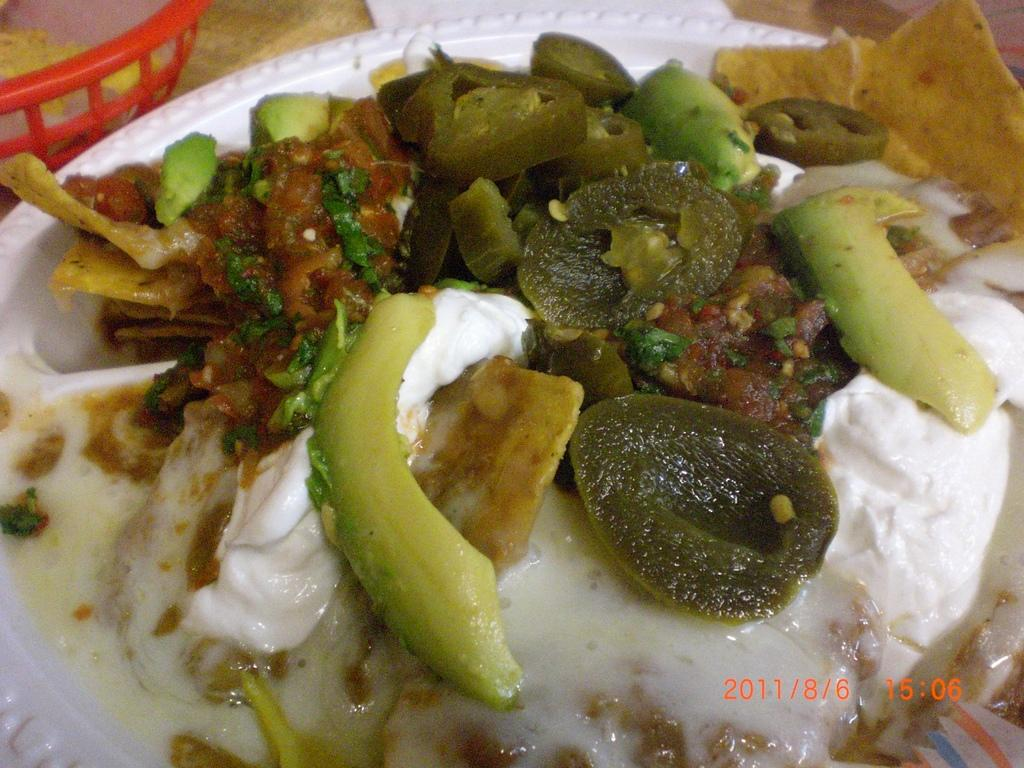What is on the plate in the image? There is curd and curry on the plate. What color is the plate? The plate is white. Can you describe any other objects in the image? There is a red color basket in the background. How is the salt arranged on the plate in the image? There is no salt present on the plate in the image. What type of string is used to tie the clover in the image? There is no string or clover present in the image. 